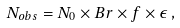<formula> <loc_0><loc_0><loc_500><loc_500>N _ { o b s } = N _ { 0 } \times B r \times f \times \epsilon \, ,</formula> 